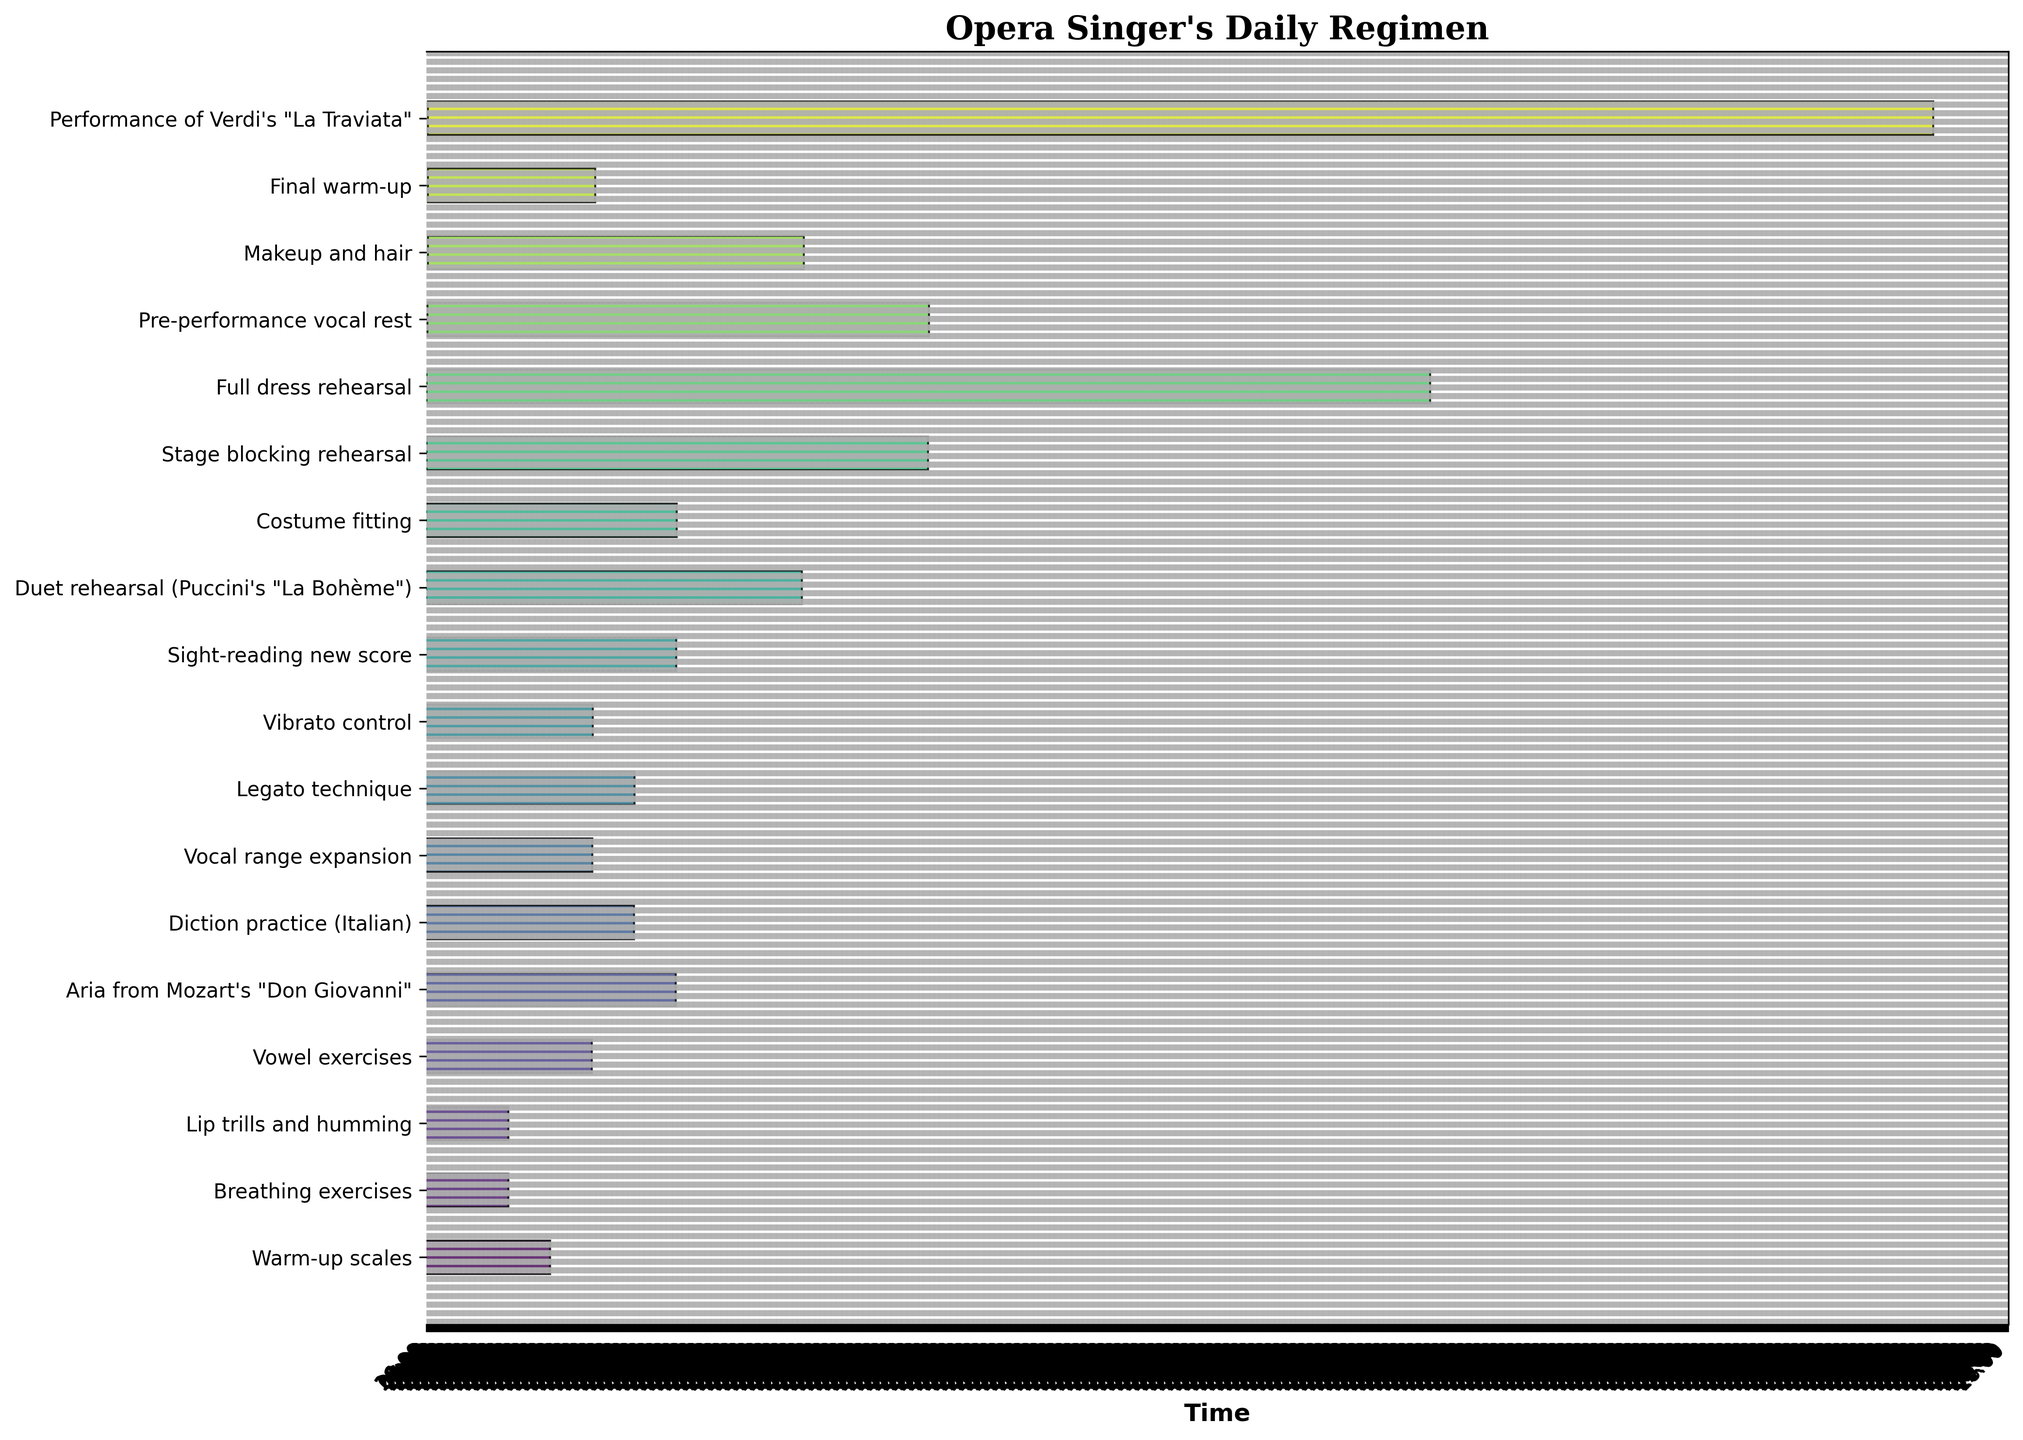What's the title of the figure? The title is usually at the top of the figure, providing a summary of what the chart depicts.
Answer: Opera Singer's Daily Regimen How many tasks are included in the regimen? Count the bars or tasks listed on the y-axis of the Gantt Chart to determine the number of tasks included.
Answer: 17 What color scheme is used in the Gantt Chart? Identify the color patterns used in the chart design, often to provide better visual distinction between tasks.
Answer: Viridis color scheme At what time does the "Aria from Mozart's 'Don Giovanni'" task start and end? Check the start and end positions of the corresponding bar on the x-axis to determine the time range for this task. The starting time is read from the x-axis at the beginning of the bar, and the ending time is read at the end of the bar.
Answer: Starts at 09:55, ends at 10:25 Which task has the longest duration? Compare the lengths of the bars in the chart to identify which task extends the farthest on the x-axis.
Answer: Performance of Verdi's "La Traviata" How long is the "Full dress rehearsal"? Read the length of the bar corresponding to this task and convert it to minutes if necessary.
Answer: 120 minutes When does the "Pre-performance vocal rest" task take place? By identifying the bar in the chart and reading its start and end times from the x-axis, we can determine when this task takes place.
Answer: 17:40 - 18:40 How many tasks are scheduled to take place after 5 PM? Count the number of bars that start at or after the 17:00 mark on the x-axis.
Answer: 4 tasks What is the total duration of all breathing-related exercises combined? Add the durations of the "Breathing exercises", "Lip trills and humming", "Vowel exercises", and "Vocal range expansion" tasks.
Answer: 60 minutes Which task immediately follows "Duet rehearsal (Puccini's 'La Bohème')" and at what time does it start? Identify the task that follows the "Duet rehearsal" in the list and then read its start time on the x-axis.
Answer: Costume fitting, starts at 1:10 PM 